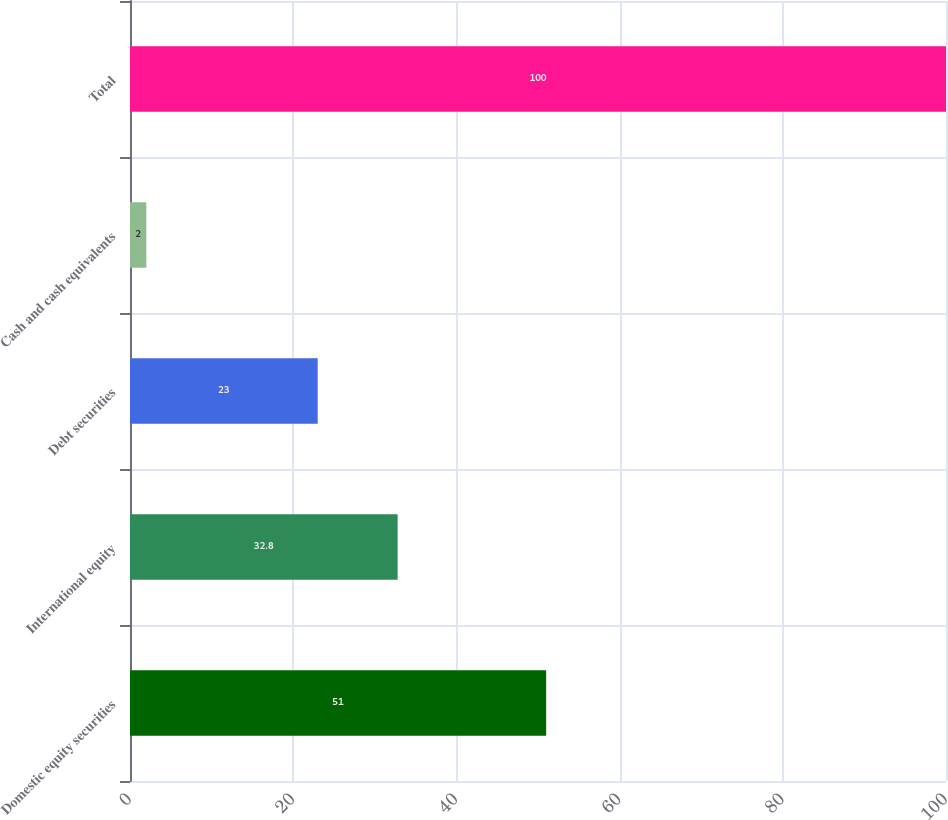Convert chart to OTSL. <chart><loc_0><loc_0><loc_500><loc_500><bar_chart><fcel>Domestic equity securities<fcel>International equity<fcel>Debt securities<fcel>Cash and cash equivalents<fcel>Total<nl><fcel>51<fcel>32.8<fcel>23<fcel>2<fcel>100<nl></chart> 